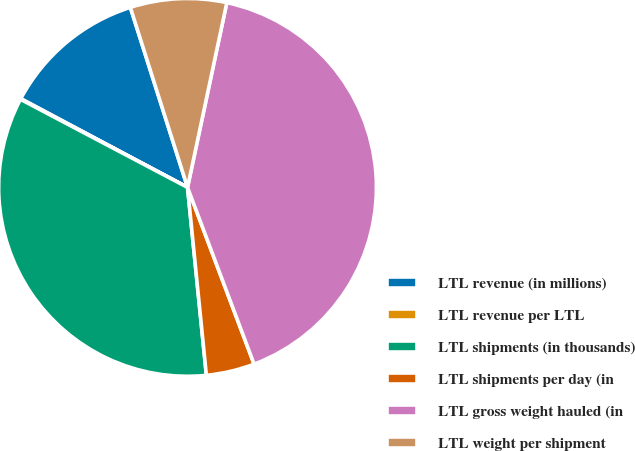<chart> <loc_0><loc_0><loc_500><loc_500><pie_chart><fcel>LTL revenue (in millions)<fcel>LTL revenue per LTL<fcel>LTL shipments (in thousands)<fcel>LTL shipments per day (in<fcel>LTL gross weight hauled (in<fcel>LTL weight per shipment<nl><fcel>12.32%<fcel>0.06%<fcel>34.31%<fcel>4.14%<fcel>40.93%<fcel>8.23%<nl></chart> 